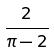Convert formula to latex. <formula><loc_0><loc_0><loc_500><loc_500>\frac { 2 } { \pi - 2 }</formula> 